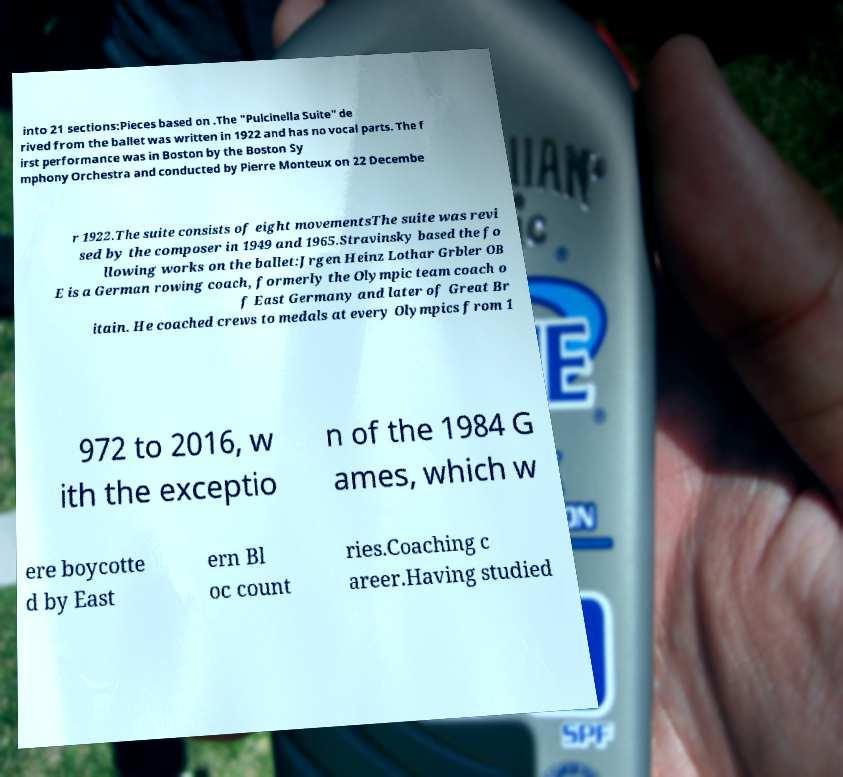Could you extract and type out the text from this image? into 21 sections:Pieces based on .The "Pulcinella Suite" de rived from the ballet was written in 1922 and has no vocal parts. The f irst performance was in Boston by the Boston Sy mphony Orchestra and conducted by Pierre Monteux on 22 Decembe r 1922.The suite consists of eight movementsThe suite was revi sed by the composer in 1949 and 1965.Stravinsky based the fo llowing works on the ballet:Jrgen Heinz Lothar Grbler OB E is a German rowing coach, formerly the Olympic team coach o f East Germany and later of Great Br itain. He coached crews to medals at every Olympics from 1 972 to 2016, w ith the exceptio n of the 1984 G ames, which w ere boycotte d by East ern Bl oc count ries.Coaching c areer.Having studied 